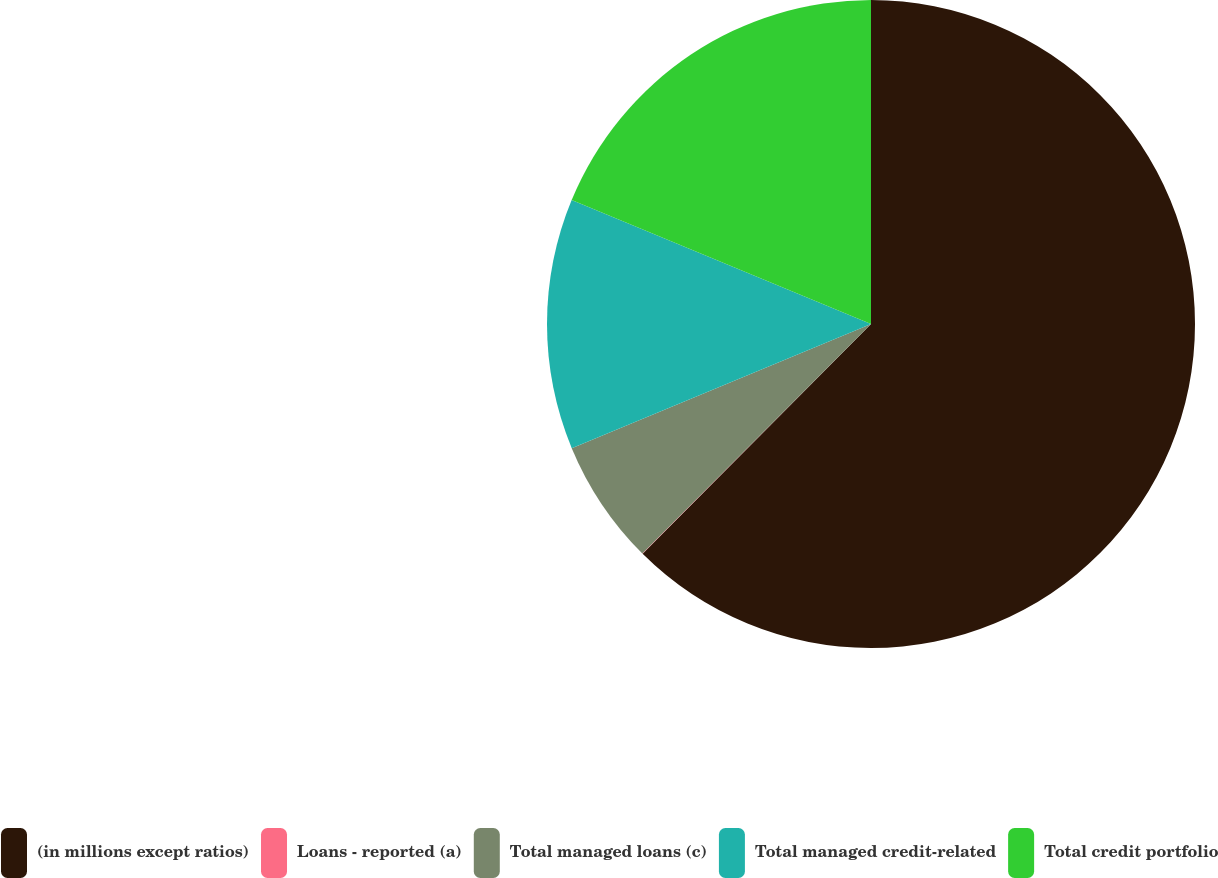Convert chart. <chart><loc_0><loc_0><loc_500><loc_500><pie_chart><fcel>(in millions except ratios)<fcel>Loans - reported (a)<fcel>Total managed loans (c)<fcel>Total managed credit-related<fcel>Total credit portfolio<nl><fcel>62.45%<fcel>0.02%<fcel>6.27%<fcel>12.51%<fcel>18.75%<nl></chart> 